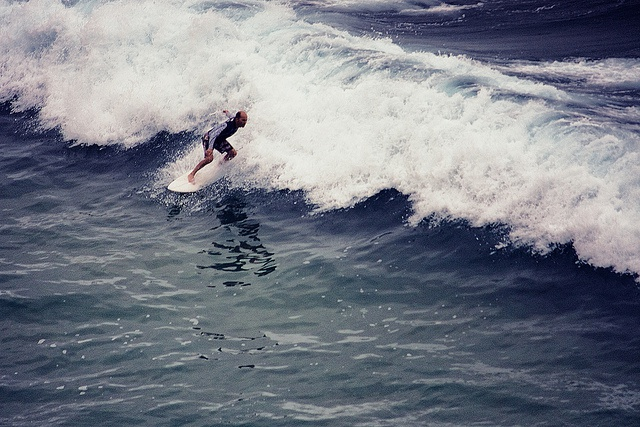Describe the objects in this image and their specific colors. I can see people in darkgray, black, brown, and purple tones and surfboard in darkgray and lightgray tones in this image. 